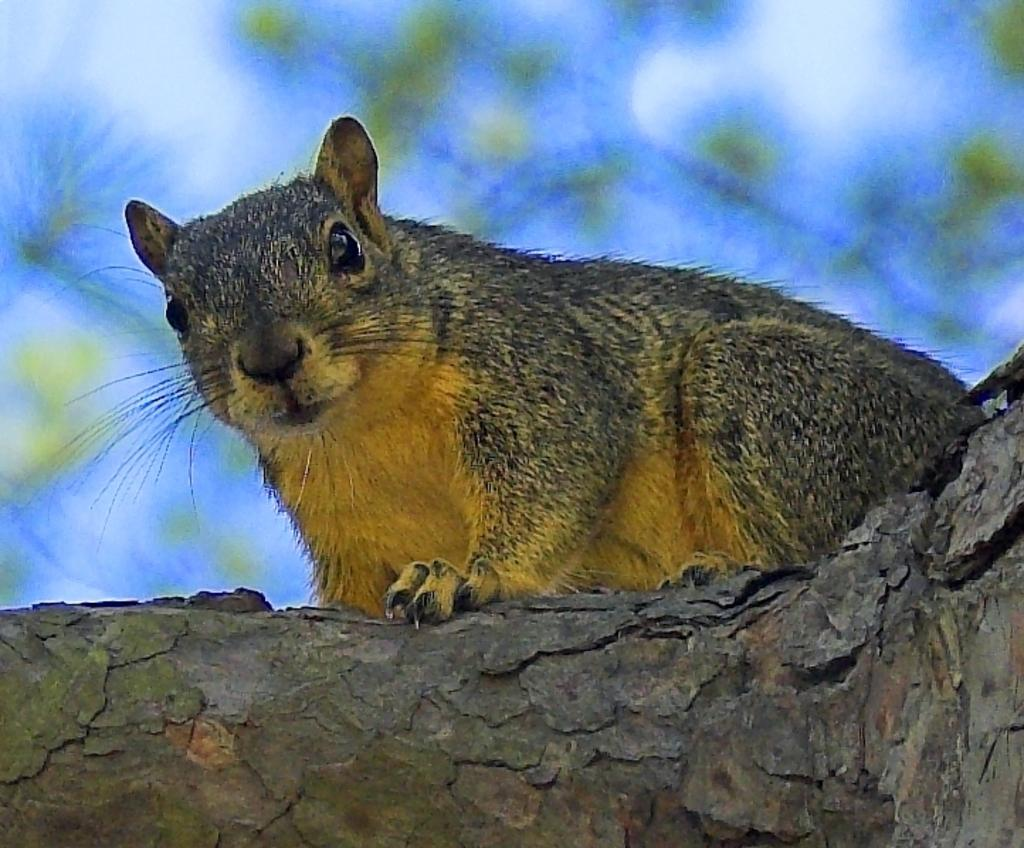What animal is present in the image? There is a squirrel in the image. What colors can be seen on the squirrel? The squirrel has yellow and grey colors. Where is the squirrel located in the image? The squirrel is on a tree branch. What can be seen in the background of the image? There is sky visible in the background of the image. How many lizards are playing the game on the string in the image? There are no lizards or strings present in the image; it features a squirrel on a tree branch with a sky background. 